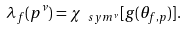<formula> <loc_0><loc_0><loc_500><loc_500>\lambda _ { f } ( p ^ { \nu } ) = \chi _ { \ s y m ^ { \nu } } [ g ( \theta _ { f , p } ) ] .</formula> 